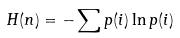<formula> <loc_0><loc_0><loc_500><loc_500>H ( n ) = - \sum p ( i ) \ln p ( i )</formula> 